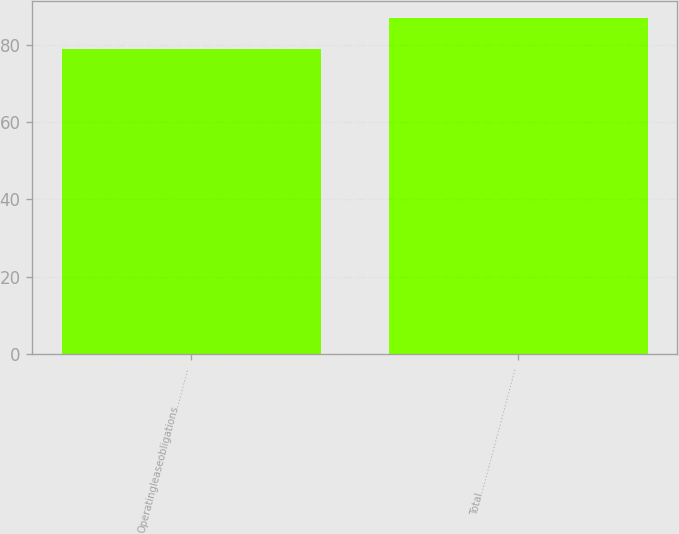<chart> <loc_0><loc_0><loc_500><loc_500><bar_chart><fcel>Operatingleaseobligations…………<fcel>Total…………………………………<nl><fcel>78.9<fcel>86.9<nl></chart> 